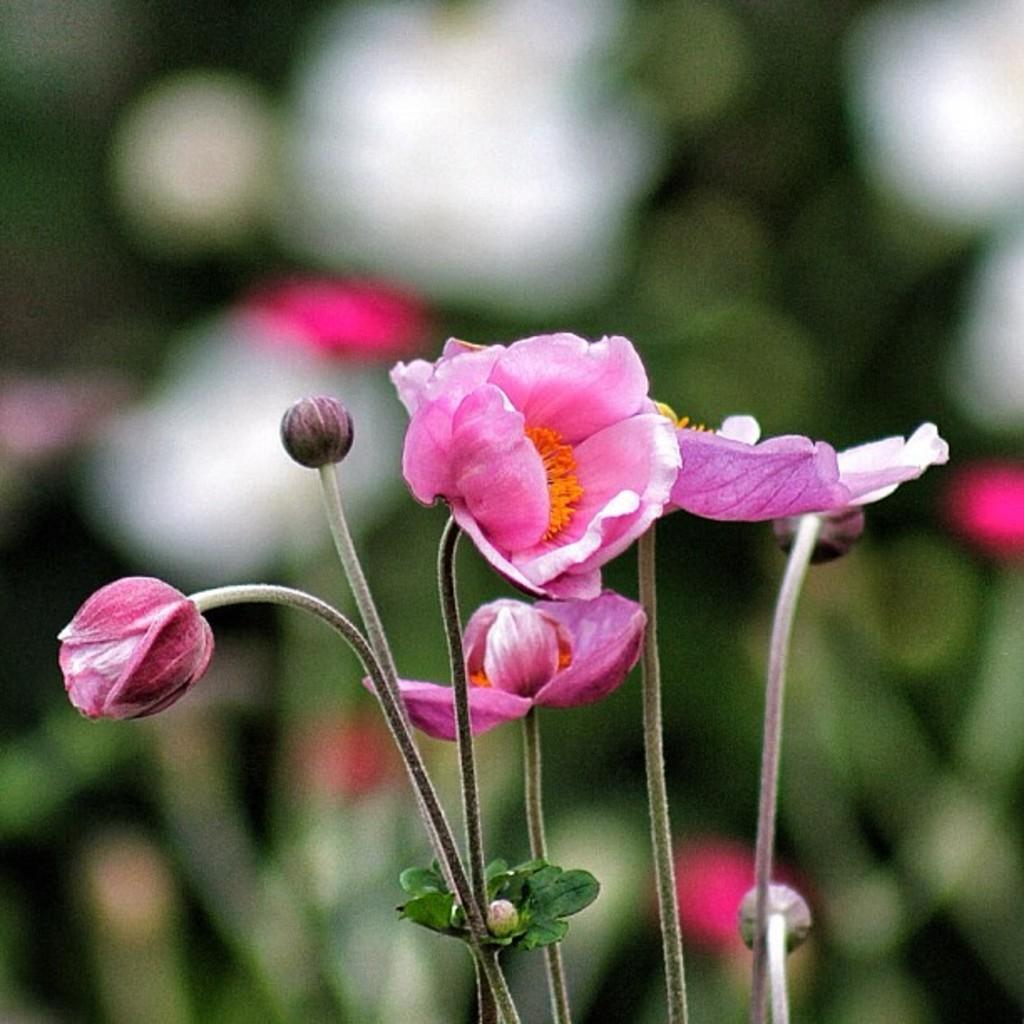What is present in the image? There are flowers in the image. Can you describe the background of the image? The background of the image is blurred. What type of boundary can be seen in the image? There is no boundary present in the image; it features flowers and a blurred background. Are there any police officers visible in the image? There are no police officers present in the image. 